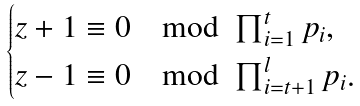Convert formula to latex. <formula><loc_0><loc_0><loc_500><loc_500>\begin{cases} z + 1 \equiv 0 \mod \prod _ { i = 1 } ^ { t } p _ { i } , \\ z - 1 \equiv 0 \mod \prod _ { i = t + 1 } ^ { l } p _ { i } . \end{cases}</formula> 